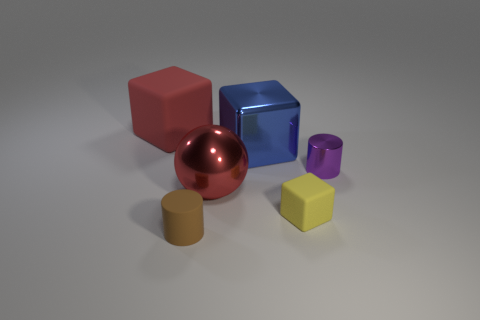Subtract all brown cylinders. Subtract all blue blocks. How many cylinders are left? 1 Add 3 blue things. How many objects exist? 9 Subtract all cylinders. How many objects are left? 4 Add 6 small yellow cubes. How many small yellow cubes are left? 7 Add 6 red metallic balls. How many red metallic balls exist? 7 Subtract 0 gray cubes. How many objects are left? 6 Subtract all purple shiny cylinders. Subtract all tiny things. How many objects are left? 2 